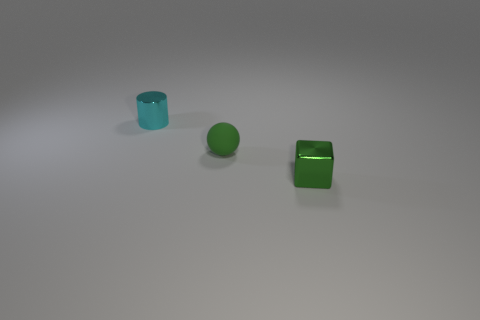The tiny green object that is left of the green thing in front of the small green object to the left of the green shiny cube is made of what material?
Your response must be concise. Rubber. How many other things are there of the same size as the green rubber thing?
Offer a terse response. 2. The small matte sphere has what color?
Provide a succinct answer. Green. What number of matte objects are either small blue cylinders or cyan objects?
Make the answer very short. 0. Are there any other things that have the same material as the tiny block?
Your response must be concise. Yes. There is a object in front of the green thing that is left of the metal object right of the small cyan metallic cylinder; what size is it?
Your answer should be very brief. Small. How big is the thing that is both in front of the tiny cylinder and behind the green cube?
Provide a succinct answer. Small. There is a metal object that is in front of the small cyan metal cylinder; is its color the same as the shiny object that is behind the green shiny object?
Keep it short and to the point. No. There is a cyan metal thing; how many things are behind it?
Your answer should be very brief. 0. Are there any cyan shiny objects right of the shiny object behind the green object to the right of the rubber sphere?
Offer a terse response. No. 